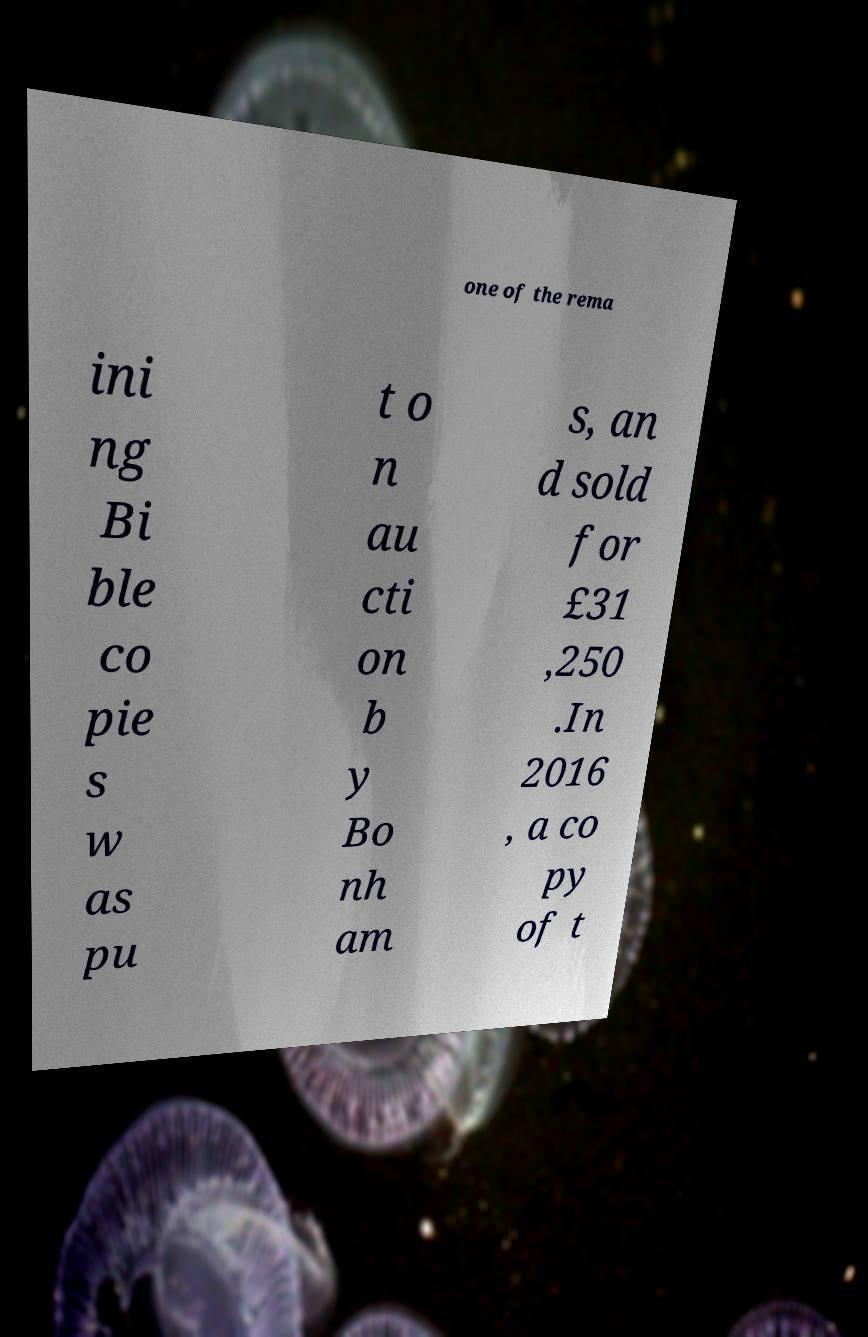There's text embedded in this image that I need extracted. Can you transcribe it verbatim? one of the rema ini ng Bi ble co pie s w as pu t o n au cti on b y Bo nh am s, an d sold for £31 ,250 .In 2016 , a co py of t 